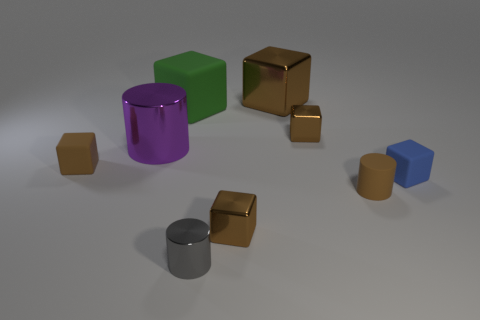Is the big cylinder the same color as the large metallic cube? no 